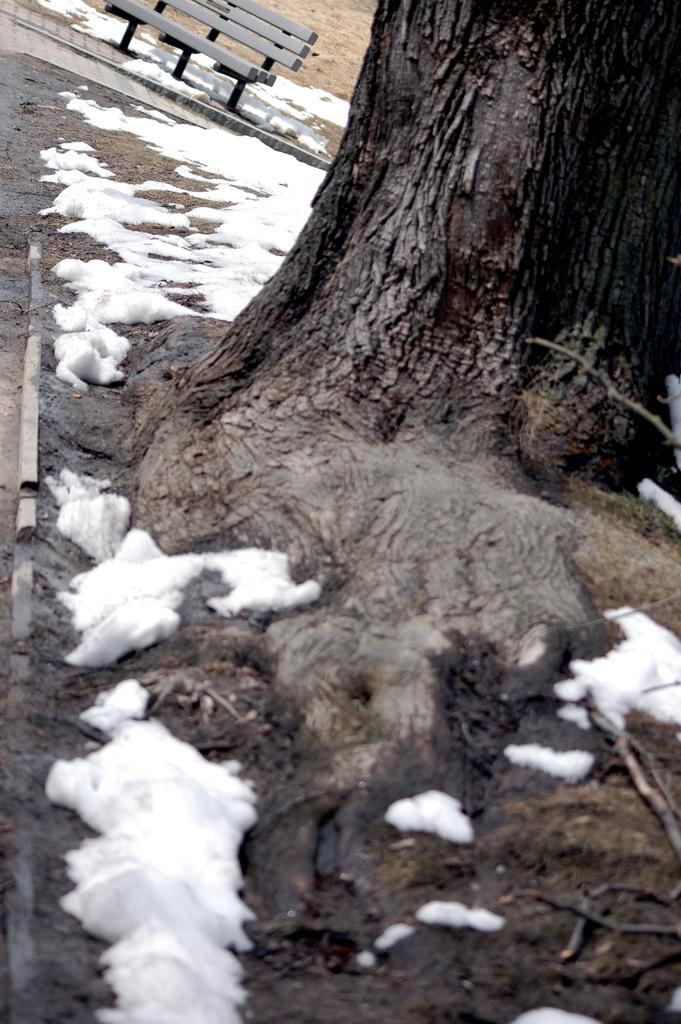What is the predominant weather condition in the image? There is snow in the image, indicating a cold and wintry condition. What type of natural element is present in the image? There is a tree in the image. What man-made structure can be seen behind the tree? There is a bench on a path behind the tree. What type of chin is visible on the tree in the image? There is no chin present in the image; it features a tree with snow and a bench on a path. 